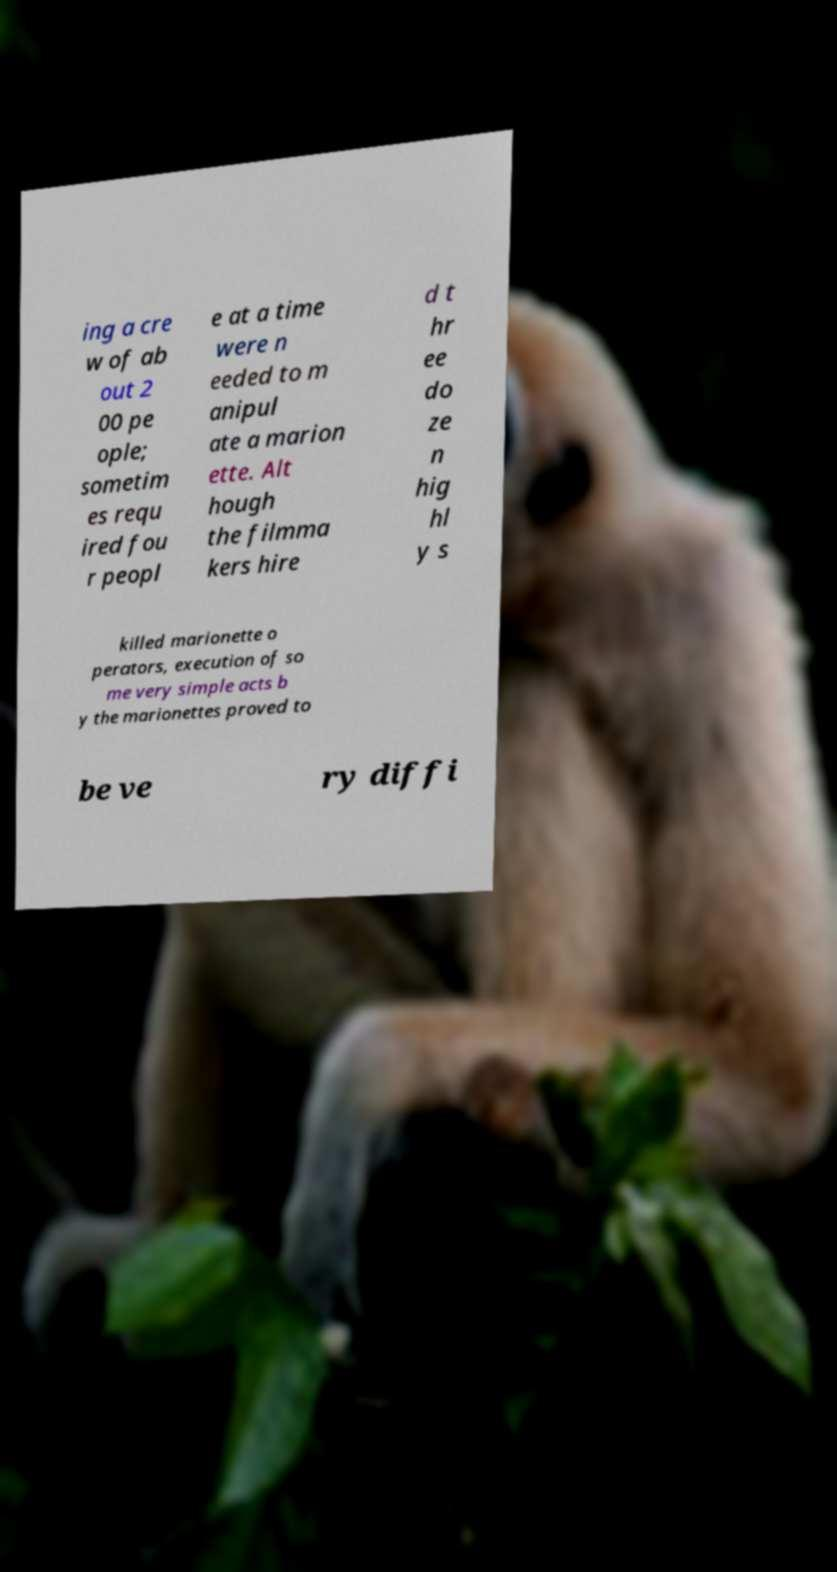For documentation purposes, I need the text within this image transcribed. Could you provide that? ing a cre w of ab out 2 00 pe ople; sometim es requ ired fou r peopl e at a time were n eeded to m anipul ate a marion ette. Alt hough the filmma kers hire d t hr ee do ze n hig hl y s killed marionette o perators, execution of so me very simple acts b y the marionettes proved to be ve ry diffi 